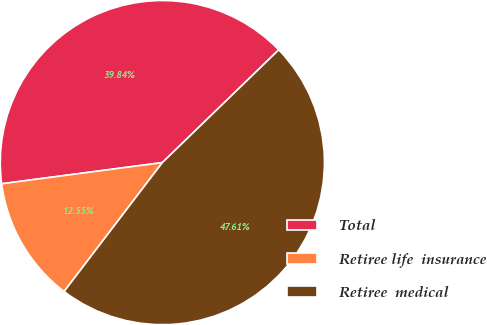<chart> <loc_0><loc_0><loc_500><loc_500><pie_chart><fcel>Total<fcel>Retiree life  insurance<fcel>Retiree  medical<nl><fcel>39.84%<fcel>12.55%<fcel>47.61%<nl></chart> 